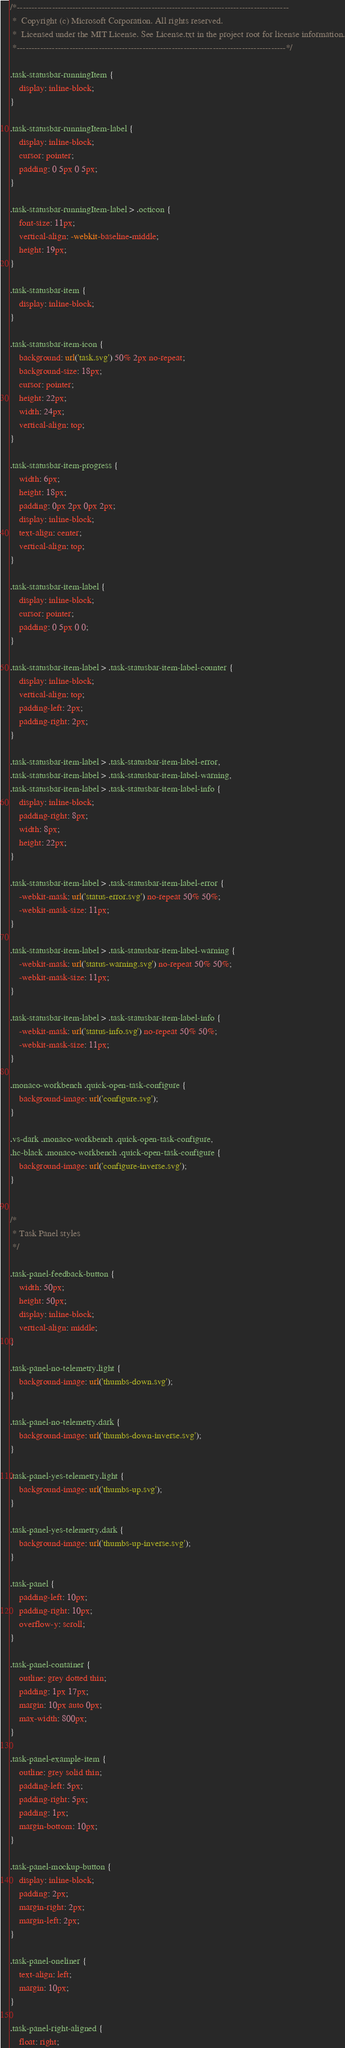<code> <loc_0><loc_0><loc_500><loc_500><_CSS_>/*---------------------------------------------------------------------------------------------
 *  Copyright (c) Microsoft Corporation. All rights reserved.
 *  Licensed under the MIT License. See License.txt in the project root for license information.
 *--------------------------------------------------------------------------------------------*/

.task-statusbar-runningItem {
	display: inline-block;
}

.task-statusbar-runningItem-label {
	display: inline-block;
	cursor: pointer;
	padding: 0 5px 0 5px;
}

.task-statusbar-runningItem-label > .octicon {
	font-size: 11px;
	vertical-align: -webkit-baseline-middle;
	height: 19px;
}

.task-statusbar-item {
	display: inline-block;
}

.task-statusbar-item-icon {
	background: url('task.svg') 50% 2px no-repeat;
	background-size: 18px;
	cursor: pointer;
	height: 22px;
	width: 24px;
	vertical-align: top;
}

.task-statusbar-item-progress {
	width: 6px;
	height: 18px;
	padding: 0px 2px 0px 2px;
	display: inline-block;
	text-align: center;
	vertical-align: top;
}

.task-statusbar-item-label {
	display: inline-block;
	cursor: pointer;
	padding: 0 5px 0 0;
}

.task-statusbar-item-label > .task-statusbar-item-label-counter {
	display: inline-block;
	vertical-align: top;
	padding-left: 2px;
	padding-right: 2px;
}

.task-statusbar-item-label > .task-statusbar-item-label-error,
.task-statusbar-item-label > .task-statusbar-item-label-warning,
.task-statusbar-item-label > .task-statusbar-item-label-info {
	display: inline-block;
	padding-right: 8px;
	width: 8px;
	height: 22px;
}

.task-statusbar-item-label > .task-statusbar-item-label-error {
	-webkit-mask: url('status-error.svg') no-repeat 50% 50%;
	-webkit-mask-size: 11px;
}

.task-statusbar-item-label > .task-statusbar-item-label-warning {
	-webkit-mask: url('status-warning.svg') no-repeat 50% 50%;
	-webkit-mask-size: 11px;
}

.task-statusbar-item-label > .task-statusbar-item-label-info {
	-webkit-mask: url('status-info.svg') no-repeat 50% 50%;
	-webkit-mask-size: 11px;
}

.monaco-workbench .quick-open-task-configure {
	background-image: url('configure.svg');
}

.vs-dark .monaco-workbench .quick-open-task-configure,
.hc-black .monaco-workbench .quick-open-task-configure {
	background-image: url('configure-inverse.svg');
}


/*
 * Task Panel styles
 */

.task-panel-feedback-button {
	width: 50px;
	height: 50px;
	display: inline-block;
	vertical-align: middle;
}

.task-panel-no-telemetry.light {
	background-image: url('thumbs-down.svg');
}

.task-panel-no-telemetry.dark {
	background-image: url('thumbs-down-inverse.svg');
}

.task-panel-yes-telemetry.light {
	background-image: url('thumbs-up.svg');
}

.task-panel-yes-telemetry.dark {
	background-image: url('thumbs-up-inverse.svg');
}

.task-panel {
	padding-left: 10px;
	padding-right: 10px;
	overflow-y: scroll;
}

.task-panel-container {
	outline: grey dotted thin;
	padding: 1px 17px;
	margin: 10px auto 0px;
	max-width: 800px;
}

.task-panel-example-item {
	outline: grey solid thin;
	padding-left: 5px;
	padding-right: 5px;
	padding: 1px;
	margin-bottom: 10px;
}

.task-panel-mockup-button {
	display: inline-block;
	padding: 2px;
	margin-right: 2px;
	margin-left: 2px;
}

.task-panel-oneliner {
	text-align: left;
	margin: 10px;
}

.task-panel-right-aligned {
	float: right;</code> 